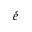<formula> <loc_0><loc_0><loc_500><loc_500>\acute { e }</formula> 